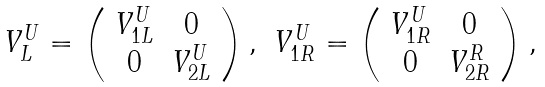Convert formula to latex. <formula><loc_0><loc_0><loc_500><loc_500>\begin{array} { c c } { { V _ { L } ^ { U } = \left ( \begin{array} { c c } { { V _ { 1 L } ^ { U } } } & { 0 } \\ { 0 } & { { V _ { 2 L } ^ { U } } } \end{array} \right ) , } } & { { V _ { 1 R } ^ { U } = \left ( \begin{array} { c c } { { V _ { 1 R } ^ { U } } } & { 0 } \\ { 0 } & { { V _ { 2 R } ^ { R } } } \end{array} \right ) , } } \end{array}</formula> 